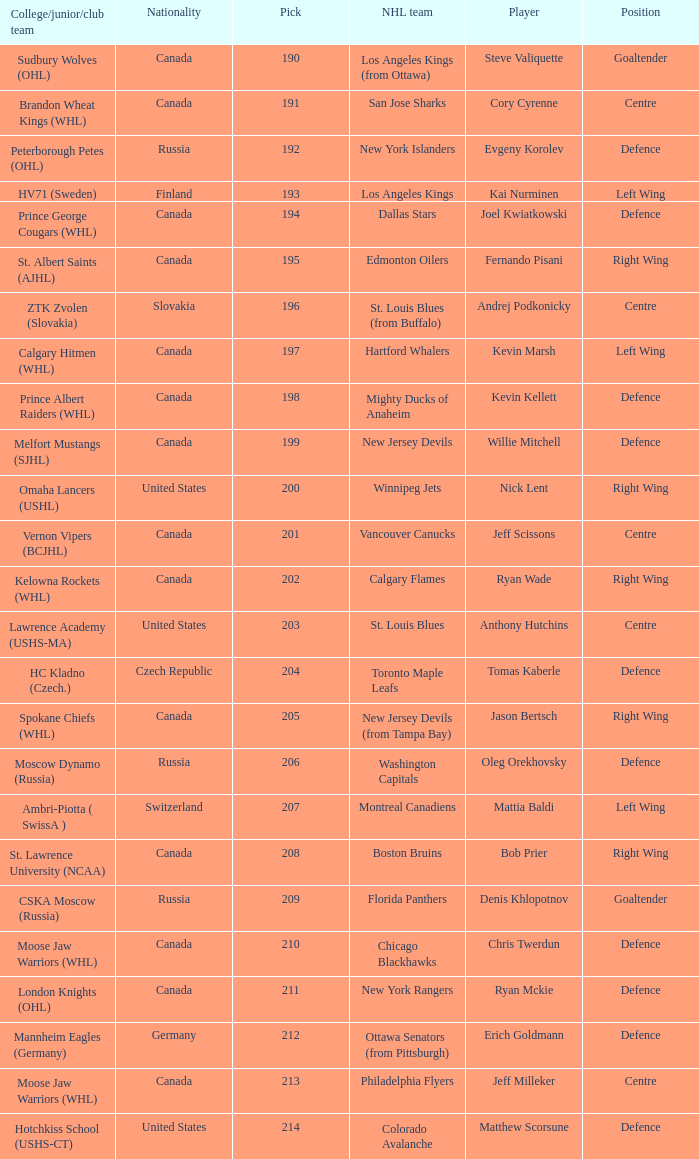Name the most pick for evgeny korolev 192.0. 